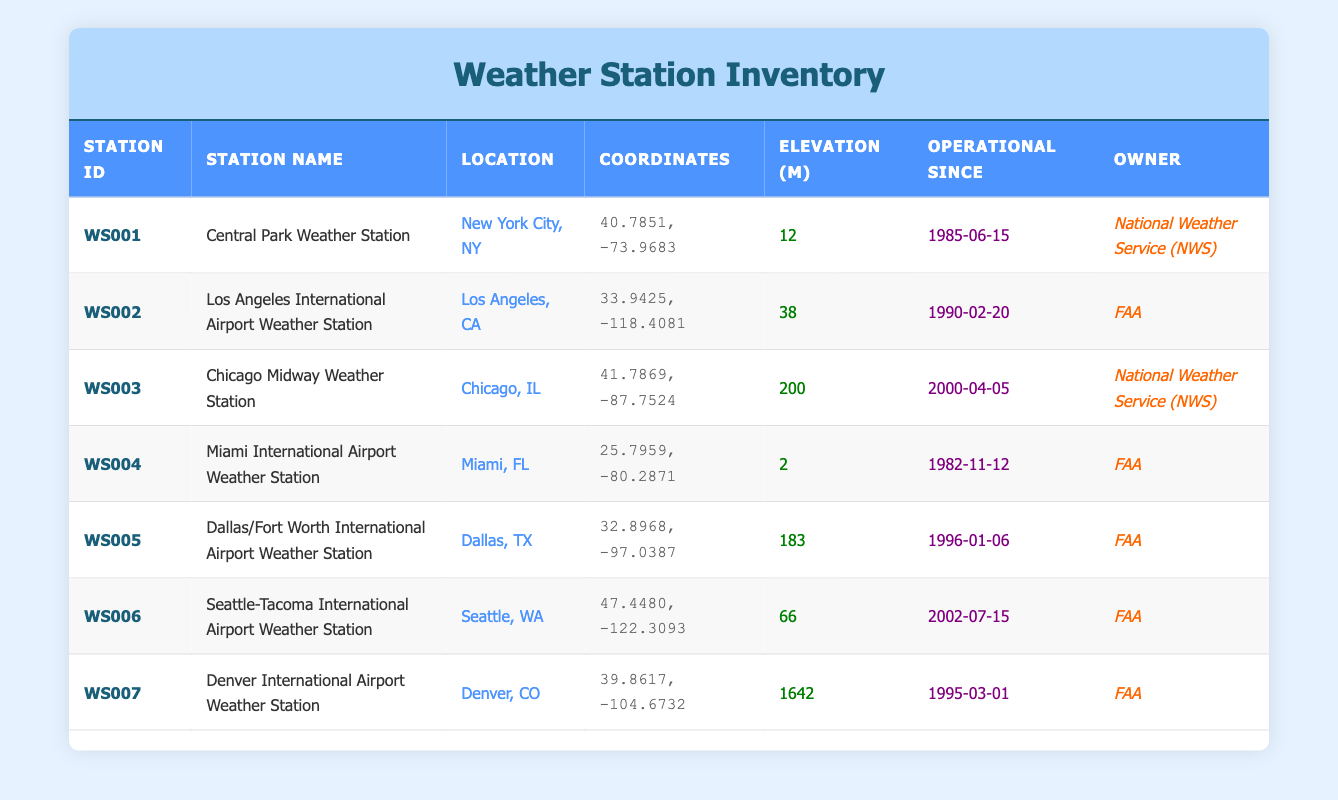What is the elevation of the Denver International Airport Weather Station? The table shows that the elevation of the Denver International Airport Weather Station (WS007) is listed under the "Elevation (m)" column, which shows a value of 1642 meters.
Answer: 1642 m Which weather station has been operational the longest? By examining the "Operational Since" column, we can see that the Central Park Weather Station (WS001) is operational since 1985-06-15, which is earlier than all other stations.
Answer: Central Park Weather Station How many weather stations are owned by the FAA? The owner for each station can be checked. By counting the rows where the "Owner" column lists "FAA", we find there are four such stations: WS002, WS004, WS005, and WS006.
Answer: 4 What is the average elevation of the weather stations? We first add the elevations of all stations: 12 + 38 + 200 + 2 + 183 + 66 + 1642 = 2143. There are 7 stations, so the average elevation is 2143 / 7 = 306.14 meters, rounding it gives approximately 306.
Answer: 306 m Is the Miami International Airport Weather Station at a higher elevation than the Seattle-Tacoma International Airport Weather Station? The elevation of Miami International Airport Weather Station (WS004) is 2 meters, while the elevation of Seattle-Tacoma International Airport Weather Station (WS006) is 66 meters. Since 2 is less than 66, the answer is no.
Answer: No Which station has the latest operational start date? Looking at the "Operational Since" dates, the latest is for the Seattle-Tacoma International Airport Weather Station (WS006), which started operationally on 2002-07-15, as it is the most recent date when compared with others.
Answer: Seattle-Tacoma International Airport Weather Station What is the total number of weather stations listed in the inventory? By counting the total rows in the table, we find there are 7 entries, each representing a different weather station. Therefore, the total number of weather stations is 7.
Answer: 7 Is it true that all weather stations are owned by either the FAA or the NWS? Reviewing the "Owner" column shows that all listed stations are either owned by the FAA or the National Weather Service (NWS) with no other owners present. Hence, the statement is true.
Answer: Yes 